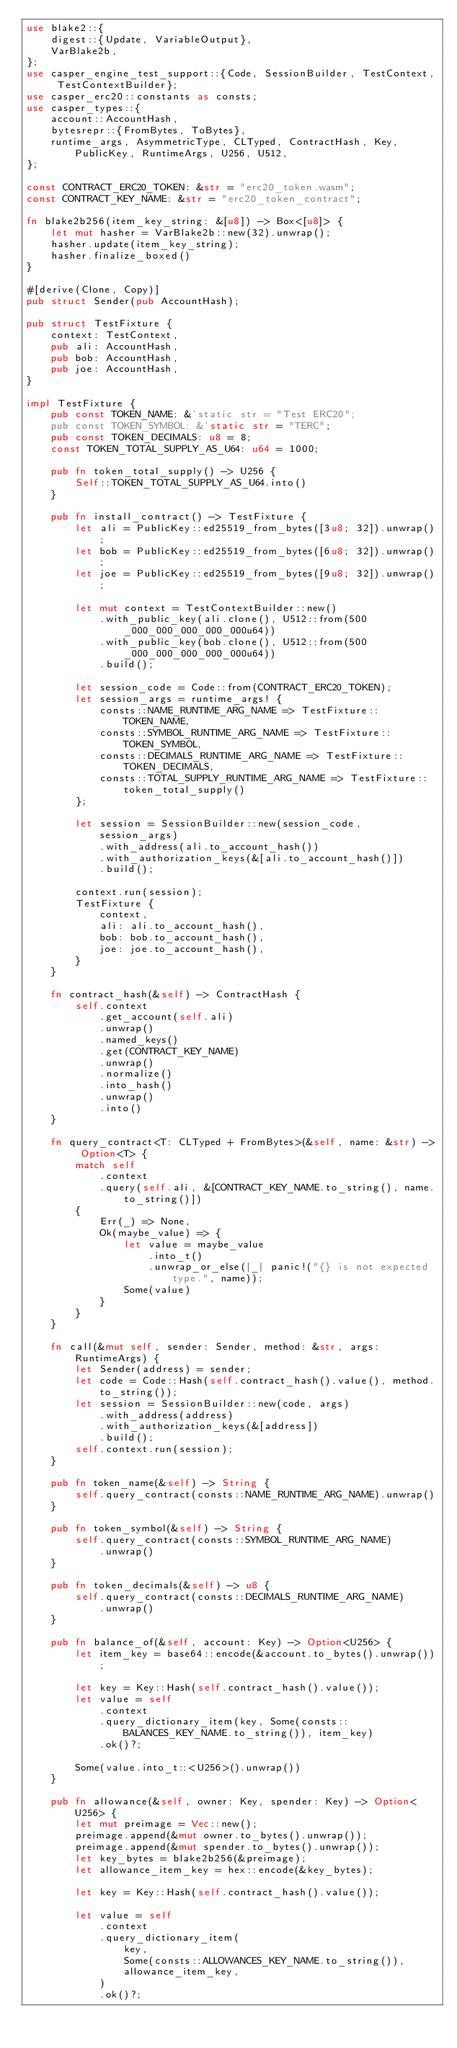Convert code to text. <code><loc_0><loc_0><loc_500><loc_500><_Rust_>use blake2::{
    digest::{Update, VariableOutput},
    VarBlake2b,
};
use casper_engine_test_support::{Code, SessionBuilder, TestContext, TestContextBuilder};
use casper_erc20::constants as consts;
use casper_types::{
    account::AccountHash,
    bytesrepr::{FromBytes, ToBytes},
    runtime_args, AsymmetricType, CLTyped, ContractHash, Key, PublicKey, RuntimeArgs, U256, U512,
};

const CONTRACT_ERC20_TOKEN: &str = "erc20_token.wasm";
const CONTRACT_KEY_NAME: &str = "erc20_token_contract";

fn blake2b256(item_key_string: &[u8]) -> Box<[u8]> {
    let mut hasher = VarBlake2b::new(32).unwrap();
    hasher.update(item_key_string);
    hasher.finalize_boxed()
}

#[derive(Clone, Copy)]
pub struct Sender(pub AccountHash);

pub struct TestFixture {
    context: TestContext,
    pub ali: AccountHash,
    pub bob: AccountHash,
    pub joe: AccountHash,
}

impl TestFixture {
    pub const TOKEN_NAME: &'static str = "Test ERC20";
    pub const TOKEN_SYMBOL: &'static str = "TERC";
    pub const TOKEN_DECIMALS: u8 = 8;
    const TOKEN_TOTAL_SUPPLY_AS_U64: u64 = 1000;

    pub fn token_total_supply() -> U256 {
        Self::TOKEN_TOTAL_SUPPLY_AS_U64.into()
    }

    pub fn install_contract() -> TestFixture {
        let ali = PublicKey::ed25519_from_bytes([3u8; 32]).unwrap();
        let bob = PublicKey::ed25519_from_bytes([6u8; 32]).unwrap();
        let joe = PublicKey::ed25519_from_bytes([9u8; 32]).unwrap();

        let mut context = TestContextBuilder::new()
            .with_public_key(ali.clone(), U512::from(500_000_000_000_000_000u64))
            .with_public_key(bob.clone(), U512::from(500_000_000_000_000_000u64))
            .build();

        let session_code = Code::from(CONTRACT_ERC20_TOKEN);
        let session_args = runtime_args! {
            consts::NAME_RUNTIME_ARG_NAME => TestFixture::TOKEN_NAME,
            consts::SYMBOL_RUNTIME_ARG_NAME => TestFixture::TOKEN_SYMBOL,
            consts::DECIMALS_RUNTIME_ARG_NAME => TestFixture::TOKEN_DECIMALS,
            consts::TOTAL_SUPPLY_RUNTIME_ARG_NAME => TestFixture::token_total_supply()
        };

        let session = SessionBuilder::new(session_code, session_args)
            .with_address(ali.to_account_hash())
            .with_authorization_keys(&[ali.to_account_hash()])
            .build();

        context.run(session);
        TestFixture {
            context,
            ali: ali.to_account_hash(),
            bob: bob.to_account_hash(),
            joe: joe.to_account_hash(),
        }
    }

    fn contract_hash(&self) -> ContractHash {
        self.context
            .get_account(self.ali)
            .unwrap()
            .named_keys()
            .get(CONTRACT_KEY_NAME)
            .unwrap()
            .normalize()
            .into_hash()
            .unwrap()
            .into()
    }

    fn query_contract<T: CLTyped + FromBytes>(&self, name: &str) -> Option<T> {
        match self
            .context
            .query(self.ali, &[CONTRACT_KEY_NAME.to_string(), name.to_string()])
        {
            Err(_) => None,
            Ok(maybe_value) => {
                let value = maybe_value
                    .into_t()
                    .unwrap_or_else(|_| panic!("{} is not expected type.", name));
                Some(value)
            }
        }
    }

    fn call(&mut self, sender: Sender, method: &str, args: RuntimeArgs) {
        let Sender(address) = sender;
        let code = Code::Hash(self.contract_hash().value(), method.to_string());
        let session = SessionBuilder::new(code, args)
            .with_address(address)
            .with_authorization_keys(&[address])
            .build();
        self.context.run(session);
    }

    pub fn token_name(&self) -> String {
        self.query_contract(consts::NAME_RUNTIME_ARG_NAME).unwrap()
    }

    pub fn token_symbol(&self) -> String {
        self.query_contract(consts::SYMBOL_RUNTIME_ARG_NAME)
            .unwrap()
    }

    pub fn token_decimals(&self) -> u8 {
        self.query_contract(consts::DECIMALS_RUNTIME_ARG_NAME)
            .unwrap()
    }

    pub fn balance_of(&self, account: Key) -> Option<U256> {
        let item_key = base64::encode(&account.to_bytes().unwrap());

        let key = Key::Hash(self.contract_hash().value());
        let value = self
            .context
            .query_dictionary_item(key, Some(consts::BALANCES_KEY_NAME.to_string()), item_key)
            .ok()?;

        Some(value.into_t::<U256>().unwrap())
    }

    pub fn allowance(&self, owner: Key, spender: Key) -> Option<U256> {
        let mut preimage = Vec::new();
        preimage.append(&mut owner.to_bytes().unwrap());
        preimage.append(&mut spender.to_bytes().unwrap());
        let key_bytes = blake2b256(&preimage);
        let allowance_item_key = hex::encode(&key_bytes);

        let key = Key::Hash(self.contract_hash().value());

        let value = self
            .context
            .query_dictionary_item(
                key,
                Some(consts::ALLOWANCES_KEY_NAME.to_string()),
                allowance_item_key,
            )
            .ok()?;
</code> 